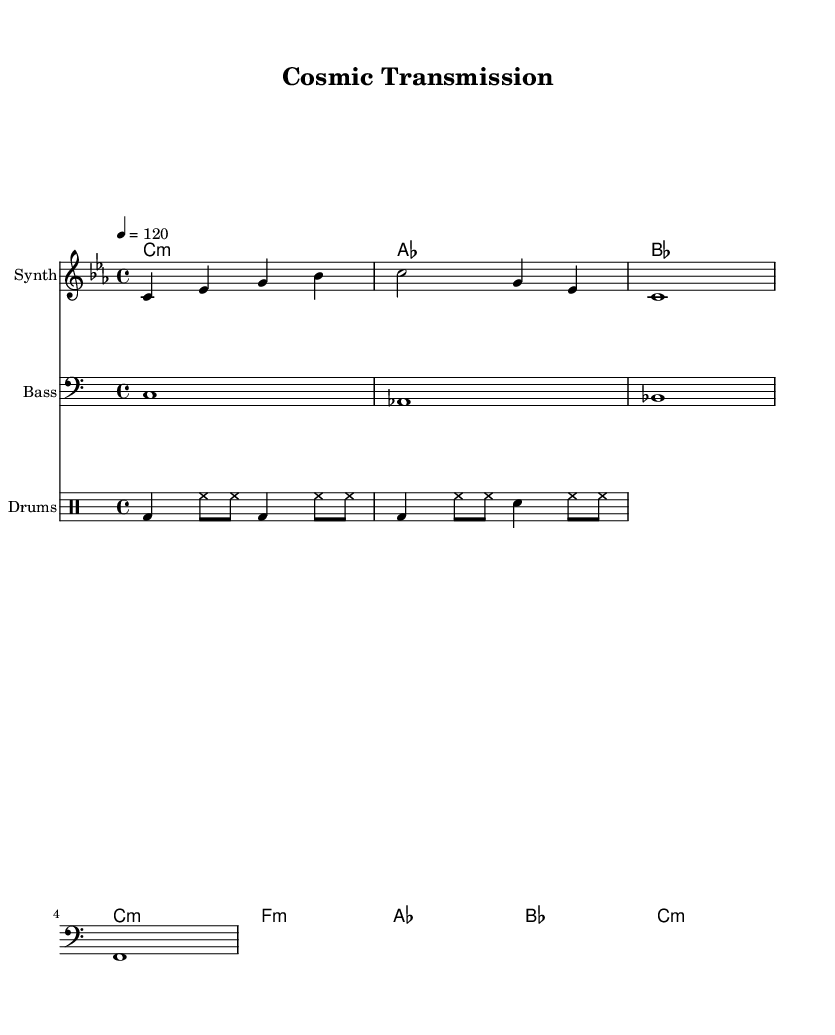What is the key signature of this music? The key signature is C minor, which has three flats (B♭, E♭, and A♭). This is determined by looking at the key signature indicated on the staff.
Answer: C minor What is the time signature used in the piece? The time signature shown in the sheet music is 4/4, which means there are four beats per measure and the quarter note receives one beat. This is evident from the notation at the beginning of the score.
Answer: 4/4 What is the tempo marking for this music? The tempo marking indicates a speed of quarter note equals 120 beats per minute, which sets the pace for how quickly the piece should be played. This can be found immediately after the time signature notation.
Answer: 120 How many measures are there in the melody? The melody part consists of four measures, and this is counted by identifying the bar lines that separate the musical phrases in the staff.
Answer: 4 What type of drum patterns are used in this piece? The drums part consists of a combination of bass drum (bd), hi-hat (hh), and snare drum (sn) patterns, which are characteristic of dance music aiming for rhythmic drive. This can be analyzed by examining the drum staff and the notation present.
Answer: Bass and hi-hat patterns Which instruments are included in the score? The score features three instruments: Synth for the melody, Bass for the bass line, and Drums for the rhythm section. This can be determined by looking at the names given to each staff in the score.
Answer: Synth, Bass, Drums What is the last chord in the harmony section? The last chord in the harmony section is C minor, shown in the final part of the harmony indications. This can be identified by looking at the chord names specified in the ChordNames section of the score.
Answer: C:m 